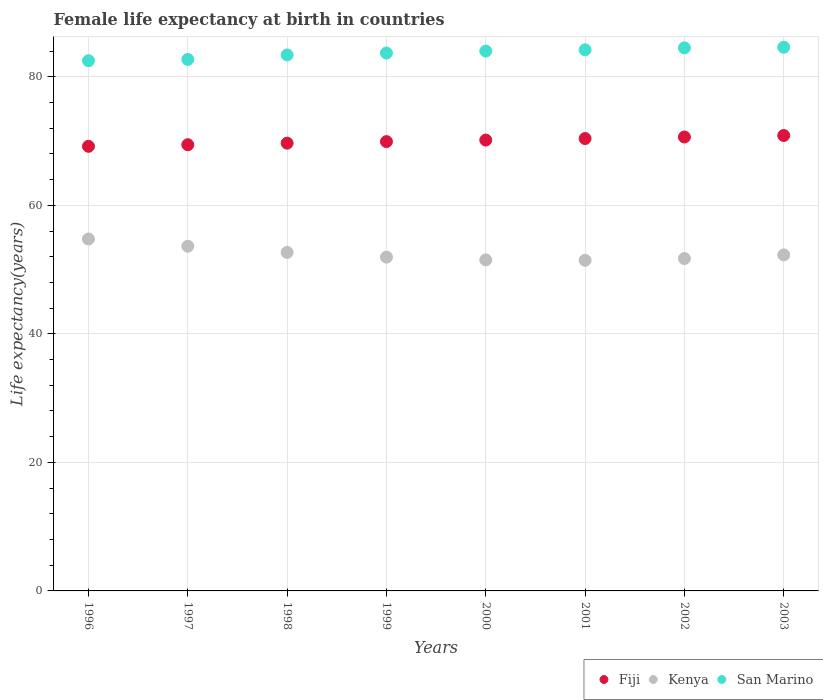How many different coloured dotlines are there?
Give a very brief answer. 3. Is the number of dotlines equal to the number of legend labels?
Your answer should be compact. Yes. What is the female life expectancy at birth in Kenya in 1998?
Offer a very short reply. 52.67. Across all years, what is the maximum female life expectancy at birth in Kenya?
Ensure brevity in your answer.  54.77. Across all years, what is the minimum female life expectancy at birth in Kenya?
Your answer should be very brief. 51.45. In which year was the female life expectancy at birth in San Marino maximum?
Your answer should be compact. 2003. What is the total female life expectancy at birth in Kenya in the graph?
Your answer should be very brief. 419.97. What is the difference between the female life expectancy at birth in Kenya in 1997 and that in 2002?
Offer a very short reply. 1.91. What is the difference between the female life expectancy at birth in San Marino in 1998 and the female life expectancy at birth in Fiji in 2000?
Provide a succinct answer. 13.25. What is the average female life expectancy at birth in Fiji per year?
Keep it short and to the point. 70.03. In the year 1996, what is the difference between the female life expectancy at birth in San Marino and female life expectancy at birth in Fiji?
Give a very brief answer. 13.32. In how many years, is the female life expectancy at birth in Fiji greater than 8 years?
Your answer should be compact. 8. What is the ratio of the female life expectancy at birth in Kenya in 2001 to that in 2002?
Keep it short and to the point. 0.99. Is the female life expectancy at birth in San Marino in 2000 less than that in 2001?
Ensure brevity in your answer.  Yes. Is the difference between the female life expectancy at birth in San Marino in 1998 and 2002 greater than the difference between the female life expectancy at birth in Fiji in 1998 and 2002?
Offer a terse response. No. What is the difference between the highest and the second highest female life expectancy at birth in San Marino?
Your answer should be compact. 0.1. What is the difference between the highest and the lowest female life expectancy at birth in Fiji?
Your answer should be compact. 1.69. Is the sum of the female life expectancy at birth in Kenya in 1997 and 2000 greater than the maximum female life expectancy at birth in Fiji across all years?
Your answer should be very brief. Yes. Is it the case that in every year, the sum of the female life expectancy at birth in Fiji and female life expectancy at birth in San Marino  is greater than the female life expectancy at birth in Kenya?
Offer a terse response. Yes. Does the female life expectancy at birth in San Marino monotonically increase over the years?
Provide a short and direct response. Yes. Is the female life expectancy at birth in San Marino strictly greater than the female life expectancy at birth in Kenya over the years?
Provide a succinct answer. Yes. Is the female life expectancy at birth in San Marino strictly less than the female life expectancy at birth in Kenya over the years?
Keep it short and to the point. No. How many dotlines are there?
Provide a succinct answer. 3. What is the difference between two consecutive major ticks on the Y-axis?
Make the answer very short. 20. Are the values on the major ticks of Y-axis written in scientific E-notation?
Ensure brevity in your answer.  No. Does the graph contain any zero values?
Provide a short and direct response. No. Where does the legend appear in the graph?
Your answer should be compact. Bottom right. How many legend labels are there?
Keep it short and to the point. 3. What is the title of the graph?
Provide a short and direct response. Female life expectancy at birth in countries. What is the label or title of the X-axis?
Provide a succinct answer. Years. What is the label or title of the Y-axis?
Keep it short and to the point. Life expectancy(years). What is the Life expectancy(years) of Fiji in 1996?
Keep it short and to the point. 69.18. What is the Life expectancy(years) in Kenya in 1996?
Provide a succinct answer. 54.77. What is the Life expectancy(years) of San Marino in 1996?
Provide a succinct answer. 82.5. What is the Life expectancy(years) of Fiji in 1997?
Give a very brief answer. 69.43. What is the Life expectancy(years) of Kenya in 1997?
Keep it short and to the point. 53.63. What is the Life expectancy(years) in San Marino in 1997?
Your answer should be very brief. 82.7. What is the Life expectancy(years) of Fiji in 1998?
Make the answer very short. 69.67. What is the Life expectancy(years) of Kenya in 1998?
Give a very brief answer. 52.67. What is the Life expectancy(years) in San Marino in 1998?
Provide a succinct answer. 83.4. What is the Life expectancy(years) of Fiji in 1999?
Make the answer very short. 69.91. What is the Life expectancy(years) in Kenya in 1999?
Provide a short and direct response. 51.94. What is the Life expectancy(years) in San Marino in 1999?
Make the answer very short. 83.7. What is the Life expectancy(years) in Fiji in 2000?
Give a very brief answer. 70.15. What is the Life expectancy(years) of Kenya in 2000?
Give a very brief answer. 51.51. What is the Life expectancy(years) of San Marino in 2000?
Provide a succinct answer. 84. What is the Life expectancy(years) of Fiji in 2001?
Make the answer very short. 70.39. What is the Life expectancy(years) of Kenya in 2001?
Ensure brevity in your answer.  51.45. What is the Life expectancy(years) in San Marino in 2001?
Make the answer very short. 84.2. What is the Life expectancy(years) of Fiji in 2002?
Provide a short and direct response. 70.63. What is the Life expectancy(years) in Kenya in 2002?
Offer a terse response. 51.72. What is the Life expectancy(years) of San Marino in 2002?
Provide a short and direct response. 84.5. What is the Life expectancy(years) of Fiji in 2003?
Make the answer very short. 70.87. What is the Life expectancy(years) of Kenya in 2003?
Offer a very short reply. 52.29. What is the Life expectancy(years) of San Marino in 2003?
Ensure brevity in your answer.  84.6. Across all years, what is the maximum Life expectancy(years) of Fiji?
Provide a short and direct response. 70.87. Across all years, what is the maximum Life expectancy(years) in Kenya?
Keep it short and to the point. 54.77. Across all years, what is the maximum Life expectancy(years) in San Marino?
Ensure brevity in your answer.  84.6. Across all years, what is the minimum Life expectancy(years) in Fiji?
Keep it short and to the point. 69.18. Across all years, what is the minimum Life expectancy(years) of Kenya?
Provide a succinct answer. 51.45. Across all years, what is the minimum Life expectancy(years) of San Marino?
Offer a very short reply. 82.5. What is the total Life expectancy(years) in Fiji in the graph?
Your response must be concise. 560.24. What is the total Life expectancy(years) of Kenya in the graph?
Make the answer very short. 419.97. What is the total Life expectancy(years) of San Marino in the graph?
Ensure brevity in your answer.  669.6. What is the difference between the Life expectancy(years) in Fiji in 1996 and that in 1997?
Provide a succinct answer. -0.25. What is the difference between the Life expectancy(years) of Kenya in 1996 and that in 1997?
Offer a terse response. 1.13. What is the difference between the Life expectancy(years) of San Marino in 1996 and that in 1997?
Provide a succinct answer. -0.2. What is the difference between the Life expectancy(years) in Fiji in 1996 and that in 1998?
Give a very brief answer. -0.49. What is the difference between the Life expectancy(years) of Kenya in 1996 and that in 1998?
Your answer should be compact. 2.1. What is the difference between the Life expectancy(years) of Fiji in 1996 and that in 1999?
Offer a very short reply. -0.73. What is the difference between the Life expectancy(years) of Kenya in 1996 and that in 1999?
Your answer should be compact. 2.83. What is the difference between the Life expectancy(years) in San Marino in 1996 and that in 1999?
Provide a short and direct response. -1.2. What is the difference between the Life expectancy(years) of Fiji in 1996 and that in 2000?
Your response must be concise. -0.97. What is the difference between the Life expectancy(years) in Kenya in 1996 and that in 2000?
Offer a very short reply. 3.25. What is the difference between the Life expectancy(years) in Fiji in 1996 and that in 2001?
Keep it short and to the point. -1.21. What is the difference between the Life expectancy(years) in Kenya in 1996 and that in 2001?
Offer a terse response. 3.32. What is the difference between the Life expectancy(years) of Fiji in 1996 and that in 2002?
Ensure brevity in your answer.  -1.45. What is the difference between the Life expectancy(years) of Kenya in 1996 and that in 2002?
Make the answer very short. 3.04. What is the difference between the Life expectancy(years) of San Marino in 1996 and that in 2002?
Ensure brevity in your answer.  -2. What is the difference between the Life expectancy(years) of Fiji in 1996 and that in 2003?
Your answer should be very brief. -1.69. What is the difference between the Life expectancy(years) of Kenya in 1996 and that in 2003?
Make the answer very short. 2.48. What is the difference between the Life expectancy(years) of San Marino in 1996 and that in 2003?
Provide a succinct answer. -2.1. What is the difference between the Life expectancy(years) in Fiji in 1997 and that in 1998?
Your response must be concise. -0.24. What is the difference between the Life expectancy(years) of Kenya in 1997 and that in 1998?
Offer a very short reply. 0.96. What is the difference between the Life expectancy(years) in San Marino in 1997 and that in 1998?
Your answer should be very brief. -0.7. What is the difference between the Life expectancy(years) of Fiji in 1997 and that in 1999?
Offer a very short reply. -0.48. What is the difference between the Life expectancy(years) in Kenya in 1997 and that in 1999?
Give a very brief answer. 1.7. What is the difference between the Life expectancy(years) of San Marino in 1997 and that in 1999?
Keep it short and to the point. -1. What is the difference between the Life expectancy(years) in Fiji in 1997 and that in 2000?
Make the answer very short. -0.72. What is the difference between the Life expectancy(years) in Kenya in 1997 and that in 2000?
Keep it short and to the point. 2.12. What is the difference between the Life expectancy(years) in San Marino in 1997 and that in 2000?
Offer a terse response. -1.3. What is the difference between the Life expectancy(years) of Fiji in 1997 and that in 2001?
Provide a short and direct response. -0.96. What is the difference between the Life expectancy(years) of Kenya in 1997 and that in 2001?
Provide a short and direct response. 2.19. What is the difference between the Life expectancy(years) of Fiji in 1997 and that in 2002?
Offer a very short reply. -1.2. What is the difference between the Life expectancy(years) in Kenya in 1997 and that in 2002?
Offer a terse response. 1.91. What is the difference between the Life expectancy(years) in Fiji in 1997 and that in 2003?
Provide a short and direct response. -1.44. What is the difference between the Life expectancy(years) in Kenya in 1997 and that in 2003?
Provide a short and direct response. 1.35. What is the difference between the Life expectancy(years) of San Marino in 1997 and that in 2003?
Make the answer very short. -1.9. What is the difference between the Life expectancy(years) in Fiji in 1998 and that in 1999?
Offer a terse response. -0.24. What is the difference between the Life expectancy(years) in Kenya in 1998 and that in 1999?
Keep it short and to the point. 0.73. What is the difference between the Life expectancy(years) in Fiji in 1998 and that in 2000?
Your response must be concise. -0.48. What is the difference between the Life expectancy(years) in Kenya in 1998 and that in 2000?
Offer a very short reply. 1.16. What is the difference between the Life expectancy(years) in Fiji in 1998 and that in 2001?
Offer a terse response. -0.72. What is the difference between the Life expectancy(years) in Kenya in 1998 and that in 2001?
Provide a succinct answer. 1.22. What is the difference between the Life expectancy(years) in Fiji in 1998 and that in 2002?
Make the answer very short. -0.96. What is the difference between the Life expectancy(years) of Kenya in 1998 and that in 2002?
Keep it short and to the point. 0.95. What is the difference between the Life expectancy(years) of San Marino in 1998 and that in 2002?
Provide a succinct answer. -1.1. What is the difference between the Life expectancy(years) in Fiji in 1998 and that in 2003?
Give a very brief answer. -1.19. What is the difference between the Life expectancy(years) of Kenya in 1998 and that in 2003?
Provide a short and direct response. 0.38. What is the difference between the Life expectancy(years) of San Marino in 1998 and that in 2003?
Make the answer very short. -1.2. What is the difference between the Life expectancy(years) in Fiji in 1999 and that in 2000?
Give a very brief answer. -0.24. What is the difference between the Life expectancy(years) in Kenya in 1999 and that in 2000?
Your answer should be very brief. 0.42. What is the difference between the Life expectancy(years) of Fiji in 1999 and that in 2001?
Your response must be concise. -0.48. What is the difference between the Life expectancy(years) in Kenya in 1999 and that in 2001?
Make the answer very short. 0.49. What is the difference between the Life expectancy(years) of Fiji in 1999 and that in 2002?
Offer a terse response. -0.72. What is the difference between the Life expectancy(years) in Kenya in 1999 and that in 2002?
Give a very brief answer. 0.22. What is the difference between the Life expectancy(years) in Fiji in 1999 and that in 2003?
Keep it short and to the point. -0.95. What is the difference between the Life expectancy(years) of Kenya in 1999 and that in 2003?
Give a very brief answer. -0.35. What is the difference between the Life expectancy(years) in Fiji in 2000 and that in 2001?
Your answer should be compact. -0.24. What is the difference between the Life expectancy(years) in Kenya in 2000 and that in 2001?
Give a very brief answer. 0.07. What is the difference between the Life expectancy(years) in San Marino in 2000 and that in 2001?
Ensure brevity in your answer.  -0.2. What is the difference between the Life expectancy(years) of Fiji in 2000 and that in 2002?
Ensure brevity in your answer.  -0.48. What is the difference between the Life expectancy(years) in Kenya in 2000 and that in 2002?
Provide a short and direct response. -0.21. What is the difference between the Life expectancy(years) in San Marino in 2000 and that in 2002?
Offer a terse response. -0.5. What is the difference between the Life expectancy(years) in Fiji in 2000 and that in 2003?
Provide a succinct answer. -0.71. What is the difference between the Life expectancy(years) in Kenya in 2000 and that in 2003?
Your answer should be compact. -0.77. What is the difference between the Life expectancy(years) of San Marino in 2000 and that in 2003?
Give a very brief answer. -0.6. What is the difference between the Life expectancy(years) of Fiji in 2001 and that in 2002?
Your answer should be very brief. -0.24. What is the difference between the Life expectancy(years) of Kenya in 2001 and that in 2002?
Keep it short and to the point. -0.27. What is the difference between the Life expectancy(years) of San Marino in 2001 and that in 2002?
Ensure brevity in your answer.  -0.3. What is the difference between the Life expectancy(years) of Fiji in 2001 and that in 2003?
Your response must be concise. -0.47. What is the difference between the Life expectancy(years) in Kenya in 2001 and that in 2003?
Offer a very short reply. -0.84. What is the difference between the Life expectancy(years) of Fiji in 2002 and that in 2003?
Keep it short and to the point. -0.24. What is the difference between the Life expectancy(years) of Kenya in 2002 and that in 2003?
Your response must be concise. -0.57. What is the difference between the Life expectancy(years) of San Marino in 2002 and that in 2003?
Keep it short and to the point. -0.1. What is the difference between the Life expectancy(years) in Fiji in 1996 and the Life expectancy(years) in Kenya in 1997?
Give a very brief answer. 15.55. What is the difference between the Life expectancy(years) in Fiji in 1996 and the Life expectancy(years) in San Marino in 1997?
Offer a very short reply. -13.52. What is the difference between the Life expectancy(years) of Kenya in 1996 and the Life expectancy(years) of San Marino in 1997?
Provide a succinct answer. -27.93. What is the difference between the Life expectancy(years) in Fiji in 1996 and the Life expectancy(years) in Kenya in 1998?
Provide a succinct answer. 16.51. What is the difference between the Life expectancy(years) of Fiji in 1996 and the Life expectancy(years) of San Marino in 1998?
Keep it short and to the point. -14.22. What is the difference between the Life expectancy(years) in Kenya in 1996 and the Life expectancy(years) in San Marino in 1998?
Provide a short and direct response. -28.64. What is the difference between the Life expectancy(years) of Fiji in 1996 and the Life expectancy(years) of Kenya in 1999?
Give a very brief answer. 17.25. What is the difference between the Life expectancy(years) in Fiji in 1996 and the Life expectancy(years) in San Marino in 1999?
Ensure brevity in your answer.  -14.52. What is the difference between the Life expectancy(years) in Kenya in 1996 and the Life expectancy(years) in San Marino in 1999?
Your response must be concise. -28.93. What is the difference between the Life expectancy(years) of Fiji in 1996 and the Life expectancy(years) of Kenya in 2000?
Offer a terse response. 17.67. What is the difference between the Life expectancy(years) of Fiji in 1996 and the Life expectancy(years) of San Marino in 2000?
Provide a succinct answer. -14.82. What is the difference between the Life expectancy(years) of Kenya in 1996 and the Life expectancy(years) of San Marino in 2000?
Keep it short and to the point. -29.23. What is the difference between the Life expectancy(years) of Fiji in 1996 and the Life expectancy(years) of Kenya in 2001?
Your answer should be very brief. 17.73. What is the difference between the Life expectancy(years) of Fiji in 1996 and the Life expectancy(years) of San Marino in 2001?
Give a very brief answer. -15.02. What is the difference between the Life expectancy(years) in Kenya in 1996 and the Life expectancy(years) in San Marino in 2001?
Your answer should be compact. -29.43. What is the difference between the Life expectancy(years) in Fiji in 1996 and the Life expectancy(years) in Kenya in 2002?
Give a very brief answer. 17.46. What is the difference between the Life expectancy(years) of Fiji in 1996 and the Life expectancy(years) of San Marino in 2002?
Your response must be concise. -15.32. What is the difference between the Life expectancy(years) in Kenya in 1996 and the Life expectancy(years) in San Marino in 2002?
Make the answer very short. -29.73. What is the difference between the Life expectancy(years) in Fiji in 1996 and the Life expectancy(years) in Kenya in 2003?
Your response must be concise. 16.9. What is the difference between the Life expectancy(years) in Fiji in 1996 and the Life expectancy(years) in San Marino in 2003?
Provide a succinct answer. -15.42. What is the difference between the Life expectancy(years) in Kenya in 1996 and the Life expectancy(years) in San Marino in 2003?
Provide a short and direct response. -29.84. What is the difference between the Life expectancy(years) of Fiji in 1997 and the Life expectancy(years) of Kenya in 1998?
Offer a terse response. 16.76. What is the difference between the Life expectancy(years) of Fiji in 1997 and the Life expectancy(years) of San Marino in 1998?
Offer a very short reply. -13.97. What is the difference between the Life expectancy(years) of Kenya in 1997 and the Life expectancy(years) of San Marino in 1998?
Offer a very short reply. -29.77. What is the difference between the Life expectancy(years) in Fiji in 1997 and the Life expectancy(years) in Kenya in 1999?
Offer a terse response. 17.49. What is the difference between the Life expectancy(years) of Fiji in 1997 and the Life expectancy(years) of San Marino in 1999?
Keep it short and to the point. -14.27. What is the difference between the Life expectancy(years) in Kenya in 1997 and the Life expectancy(years) in San Marino in 1999?
Keep it short and to the point. -30.07. What is the difference between the Life expectancy(years) in Fiji in 1997 and the Life expectancy(years) in Kenya in 2000?
Your response must be concise. 17.92. What is the difference between the Life expectancy(years) in Fiji in 1997 and the Life expectancy(years) in San Marino in 2000?
Your answer should be very brief. -14.57. What is the difference between the Life expectancy(years) of Kenya in 1997 and the Life expectancy(years) of San Marino in 2000?
Provide a short and direct response. -30.37. What is the difference between the Life expectancy(years) of Fiji in 1997 and the Life expectancy(years) of Kenya in 2001?
Offer a terse response. 17.98. What is the difference between the Life expectancy(years) of Fiji in 1997 and the Life expectancy(years) of San Marino in 2001?
Offer a very short reply. -14.77. What is the difference between the Life expectancy(years) of Kenya in 1997 and the Life expectancy(years) of San Marino in 2001?
Your answer should be very brief. -30.57. What is the difference between the Life expectancy(years) in Fiji in 1997 and the Life expectancy(years) in Kenya in 2002?
Offer a terse response. 17.71. What is the difference between the Life expectancy(years) in Fiji in 1997 and the Life expectancy(years) in San Marino in 2002?
Ensure brevity in your answer.  -15.07. What is the difference between the Life expectancy(years) of Kenya in 1997 and the Life expectancy(years) of San Marino in 2002?
Give a very brief answer. -30.87. What is the difference between the Life expectancy(years) in Fiji in 1997 and the Life expectancy(years) in Kenya in 2003?
Your response must be concise. 17.14. What is the difference between the Life expectancy(years) of Fiji in 1997 and the Life expectancy(years) of San Marino in 2003?
Ensure brevity in your answer.  -15.17. What is the difference between the Life expectancy(years) in Kenya in 1997 and the Life expectancy(years) in San Marino in 2003?
Provide a short and direct response. -30.97. What is the difference between the Life expectancy(years) of Fiji in 1998 and the Life expectancy(years) of Kenya in 1999?
Your response must be concise. 17.74. What is the difference between the Life expectancy(years) of Fiji in 1998 and the Life expectancy(years) of San Marino in 1999?
Provide a short and direct response. -14.03. What is the difference between the Life expectancy(years) in Kenya in 1998 and the Life expectancy(years) in San Marino in 1999?
Your answer should be compact. -31.03. What is the difference between the Life expectancy(years) of Fiji in 1998 and the Life expectancy(years) of Kenya in 2000?
Give a very brief answer. 18.16. What is the difference between the Life expectancy(years) of Fiji in 1998 and the Life expectancy(years) of San Marino in 2000?
Make the answer very short. -14.33. What is the difference between the Life expectancy(years) of Kenya in 1998 and the Life expectancy(years) of San Marino in 2000?
Your answer should be compact. -31.33. What is the difference between the Life expectancy(years) of Fiji in 1998 and the Life expectancy(years) of Kenya in 2001?
Offer a very short reply. 18.23. What is the difference between the Life expectancy(years) of Fiji in 1998 and the Life expectancy(years) of San Marino in 2001?
Your answer should be very brief. -14.53. What is the difference between the Life expectancy(years) in Kenya in 1998 and the Life expectancy(years) in San Marino in 2001?
Provide a succinct answer. -31.53. What is the difference between the Life expectancy(years) of Fiji in 1998 and the Life expectancy(years) of Kenya in 2002?
Your answer should be compact. 17.95. What is the difference between the Life expectancy(years) of Fiji in 1998 and the Life expectancy(years) of San Marino in 2002?
Your answer should be compact. -14.83. What is the difference between the Life expectancy(years) of Kenya in 1998 and the Life expectancy(years) of San Marino in 2002?
Make the answer very short. -31.83. What is the difference between the Life expectancy(years) in Fiji in 1998 and the Life expectancy(years) in Kenya in 2003?
Offer a terse response. 17.39. What is the difference between the Life expectancy(years) in Fiji in 1998 and the Life expectancy(years) in San Marino in 2003?
Your response must be concise. -14.93. What is the difference between the Life expectancy(years) of Kenya in 1998 and the Life expectancy(years) of San Marino in 2003?
Your answer should be compact. -31.93. What is the difference between the Life expectancy(years) of Fiji in 1999 and the Life expectancy(years) of Kenya in 2000?
Offer a terse response. 18.4. What is the difference between the Life expectancy(years) in Fiji in 1999 and the Life expectancy(years) in San Marino in 2000?
Offer a very short reply. -14.09. What is the difference between the Life expectancy(years) in Kenya in 1999 and the Life expectancy(years) in San Marino in 2000?
Your response must be concise. -32.06. What is the difference between the Life expectancy(years) of Fiji in 1999 and the Life expectancy(years) of Kenya in 2001?
Provide a succinct answer. 18.47. What is the difference between the Life expectancy(years) in Fiji in 1999 and the Life expectancy(years) in San Marino in 2001?
Your answer should be compact. -14.29. What is the difference between the Life expectancy(years) of Kenya in 1999 and the Life expectancy(years) of San Marino in 2001?
Ensure brevity in your answer.  -32.26. What is the difference between the Life expectancy(years) of Fiji in 1999 and the Life expectancy(years) of Kenya in 2002?
Your response must be concise. 18.19. What is the difference between the Life expectancy(years) of Fiji in 1999 and the Life expectancy(years) of San Marino in 2002?
Provide a short and direct response. -14.59. What is the difference between the Life expectancy(years) of Kenya in 1999 and the Life expectancy(years) of San Marino in 2002?
Ensure brevity in your answer.  -32.56. What is the difference between the Life expectancy(years) of Fiji in 1999 and the Life expectancy(years) of Kenya in 2003?
Give a very brief answer. 17.63. What is the difference between the Life expectancy(years) in Fiji in 1999 and the Life expectancy(years) in San Marino in 2003?
Make the answer very short. -14.69. What is the difference between the Life expectancy(years) of Kenya in 1999 and the Life expectancy(years) of San Marino in 2003?
Make the answer very short. -32.66. What is the difference between the Life expectancy(years) of Fiji in 2000 and the Life expectancy(years) of Kenya in 2001?
Your answer should be very brief. 18.7. What is the difference between the Life expectancy(years) in Fiji in 2000 and the Life expectancy(years) in San Marino in 2001?
Your answer should be very brief. -14.05. What is the difference between the Life expectancy(years) of Kenya in 2000 and the Life expectancy(years) of San Marino in 2001?
Make the answer very short. -32.69. What is the difference between the Life expectancy(years) of Fiji in 2000 and the Life expectancy(years) of Kenya in 2002?
Provide a succinct answer. 18.43. What is the difference between the Life expectancy(years) in Fiji in 2000 and the Life expectancy(years) in San Marino in 2002?
Offer a terse response. -14.35. What is the difference between the Life expectancy(years) of Kenya in 2000 and the Life expectancy(years) of San Marino in 2002?
Ensure brevity in your answer.  -32.99. What is the difference between the Life expectancy(years) of Fiji in 2000 and the Life expectancy(years) of Kenya in 2003?
Make the answer very short. 17.87. What is the difference between the Life expectancy(years) in Fiji in 2000 and the Life expectancy(years) in San Marino in 2003?
Ensure brevity in your answer.  -14.45. What is the difference between the Life expectancy(years) of Kenya in 2000 and the Life expectancy(years) of San Marino in 2003?
Ensure brevity in your answer.  -33.09. What is the difference between the Life expectancy(years) in Fiji in 2001 and the Life expectancy(years) in Kenya in 2002?
Your response must be concise. 18.67. What is the difference between the Life expectancy(years) in Fiji in 2001 and the Life expectancy(years) in San Marino in 2002?
Your response must be concise. -14.11. What is the difference between the Life expectancy(years) in Kenya in 2001 and the Life expectancy(years) in San Marino in 2002?
Ensure brevity in your answer.  -33.05. What is the difference between the Life expectancy(years) of Fiji in 2001 and the Life expectancy(years) of Kenya in 2003?
Offer a terse response. 18.11. What is the difference between the Life expectancy(years) of Fiji in 2001 and the Life expectancy(years) of San Marino in 2003?
Offer a terse response. -14.21. What is the difference between the Life expectancy(years) of Kenya in 2001 and the Life expectancy(years) of San Marino in 2003?
Provide a short and direct response. -33.15. What is the difference between the Life expectancy(years) in Fiji in 2002 and the Life expectancy(years) in Kenya in 2003?
Your answer should be compact. 18.34. What is the difference between the Life expectancy(years) of Fiji in 2002 and the Life expectancy(years) of San Marino in 2003?
Offer a very short reply. -13.97. What is the difference between the Life expectancy(years) in Kenya in 2002 and the Life expectancy(years) in San Marino in 2003?
Ensure brevity in your answer.  -32.88. What is the average Life expectancy(years) in Fiji per year?
Your answer should be compact. 70.03. What is the average Life expectancy(years) in Kenya per year?
Your answer should be very brief. 52.5. What is the average Life expectancy(years) of San Marino per year?
Make the answer very short. 83.7. In the year 1996, what is the difference between the Life expectancy(years) in Fiji and Life expectancy(years) in Kenya?
Make the answer very short. 14.42. In the year 1996, what is the difference between the Life expectancy(years) in Fiji and Life expectancy(years) in San Marino?
Ensure brevity in your answer.  -13.32. In the year 1996, what is the difference between the Life expectancy(years) in Kenya and Life expectancy(years) in San Marino?
Keep it short and to the point. -27.73. In the year 1997, what is the difference between the Life expectancy(years) of Fiji and Life expectancy(years) of Kenya?
Offer a terse response. 15.8. In the year 1997, what is the difference between the Life expectancy(years) in Fiji and Life expectancy(years) in San Marino?
Give a very brief answer. -13.27. In the year 1997, what is the difference between the Life expectancy(years) of Kenya and Life expectancy(years) of San Marino?
Your answer should be compact. -29.07. In the year 1998, what is the difference between the Life expectancy(years) in Fiji and Life expectancy(years) in Kenya?
Offer a very short reply. 17. In the year 1998, what is the difference between the Life expectancy(years) of Fiji and Life expectancy(years) of San Marino?
Keep it short and to the point. -13.73. In the year 1998, what is the difference between the Life expectancy(years) in Kenya and Life expectancy(years) in San Marino?
Offer a terse response. -30.73. In the year 1999, what is the difference between the Life expectancy(years) of Fiji and Life expectancy(years) of Kenya?
Provide a succinct answer. 17.98. In the year 1999, what is the difference between the Life expectancy(years) in Fiji and Life expectancy(years) in San Marino?
Give a very brief answer. -13.79. In the year 1999, what is the difference between the Life expectancy(years) in Kenya and Life expectancy(years) in San Marino?
Provide a succinct answer. -31.76. In the year 2000, what is the difference between the Life expectancy(years) of Fiji and Life expectancy(years) of Kenya?
Offer a very short reply. 18.64. In the year 2000, what is the difference between the Life expectancy(years) of Fiji and Life expectancy(years) of San Marino?
Your response must be concise. -13.85. In the year 2000, what is the difference between the Life expectancy(years) of Kenya and Life expectancy(years) of San Marino?
Provide a short and direct response. -32.49. In the year 2001, what is the difference between the Life expectancy(years) in Fiji and Life expectancy(years) in Kenya?
Offer a very short reply. 18.94. In the year 2001, what is the difference between the Life expectancy(years) of Fiji and Life expectancy(years) of San Marino?
Your response must be concise. -13.81. In the year 2001, what is the difference between the Life expectancy(years) in Kenya and Life expectancy(years) in San Marino?
Ensure brevity in your answer.  -32.75. In the year 2002, what is the difference between the Life expectancy(years) of Fiji and Life expectancy(years) of Kenya?
Provide a short and direct response. 18.91. In the year 2002, what is the difference between the Life expectancy(years) of Fiji and Life expectancy(years) of San Marino?
Your response must be concise. -13.87. In the year 2002, what is the difference between the Life expectancy(years) of Kenya and Life expectancy(years) of San Marino?
Your answer should be compact. -32.78. In the year 2003, what is the difference between the Life expectancy(years) of Fiji and Life expectancy(years) of Kenya?
Your response must be concise. 18.58. In the year 2003, what is the difference between the Life expectancy(years) in Fiji and Life expectancy(years) in San Marino?
Your answer should be very brief. -13.73. In the year 2003, what is the difference between the Life expectancy(years) of Kenya and Life expectancy(years) of San Marino?
Offer a very short reply. -32.31. What is the ratio of the Life expectancy(years) of Kenya in 1996 to that in 1997?
Give a very brief answer. 1.02. What is the ratio of the Life expectancy(years) in San Marino in 1996 to that in 1997?
Offer a terse response. 1. What is the ratio of the Life expectancy(years) of Fiji in 1996 to that in 1998?
Offer a terse response. 0.99. What is the ratio of the Life expectancy(years) of Kenya in 1996 to that in 1998?
Make the answer very short. 1.04. What is the ratio of the Life expectancy(years) of San Marino in 1996 to that in 1998?
Provide a short and direct response. 0.99. What is the ratio of the Life expectancy(years) in Kenya in 1996 to that in 1999?
Keep it short and to the point. 1.05. What is the ratio of the Life expectancy(years) of San Marino in 1996 to that in 1999?
Ensure brevity in your answer.  0.99. What is the ratio of the Life expectancy(years) in Fiji in 1996 to that in 2000?
Your answer should be compact. 0.99. What is the ratio of the Life expectancy(years) of Kenya in 1996 to that in 2000?
Ensure brevity in your answer.  1.06. What is the ratio of the Life expectancy(years) of San Marino in 1996 to that in 2000?
Provide a succinct answer. 0.98. What is the ratio of the Life expectancy(years) in Fiji in 1996 to that in 2001?
Ensure brevity in your answer.  0.98. What is the ratio of the Life expectancy(years) in Kenya in 1996 to that in 2001?
Offer a very short reply. 1.06. What is the ratio of the Life expectancy(years) of San Marino in 1996 to that in 2001?
Offer a terse response. 0.98. What is the ratio of the Life expectancy(years) in Fiji in 1996 to that in 2002?
Offer a very short reply. 0.98. What is the ratio of the Life expectancy(years) of Kenya in 1996 to that in 2002?
Give a very brief answer. 1.06. What is the ratio of the Life expectancy(years) in San Marino in 1996 to that in 2002?
Offer a very short reply. 0.98. What is the ratio of the Life expectancy(years) in Fiji in 1996 to that in 2003?
Your response must be concise. 0.98. What is the ratio of the Life expectancy(years) of Kenya in 1996 to that in 2003?
Your answer should be compact. 1.05. What is the ratio of the Life expectancy(years) in San Marino in 1996 to that in 2003?
Keep it short and to the point. 0.98. What is the ratio of the Life expectancy(years) of Kenya in 1997 to that in 1998?
Offer a terse response. 1.02. What is the ratio of the Life expectancy(years) in Fiji in 1997 to that in 1999?
Make the answer very short. 0.99. What is the ratio of the Life expectancy(years) of Kenya in 1997 to that in 1999?
Your answer should be very brief. 1.03. What is the ratio of the Life expectancy(years) of Kenya in 1997 to that in 2000?
Your answer should be compact. 1.04. What is the ratio of the Life expectancy(years) in San Marino in 1997 to that in 2000?
Your response must be concise. 0.98. What is the ratio of the Life expectancy(years) of Fiji in 1997 to that in 2001?
Ensure brevity in your answer.  0.99. What is the ratio of the Life expectancy(years) in Kenya in 1997 to that in 2001?
Offer a very short reply. 1.04. What is the ratio of the Life expectancy(years) in San Marino in 1997 to that in 2001?
Give a very brief answer. 0.98. What is the ratio of the Life expectancy(years) in Kenya in 1997 to that in 2002?
Your answer should be very brief. 1.04. What is the ratio of the Life expectancy(years) in San Marino in 1997 to that in 2002?
Your answer should be compact. 0.98. What is the ratio of the Life expectancy(years) in Fiji in 1997 to that in 2003?
Keep it short and to the point. 0.98. What is the ratio of the Life expectancy(years) of Kenya in 1997 to that in 2003?
Give a very brief answer. 1.03. What is the ratio of the Life expectancy(years) of San Marino in 1997 to that in 2003?
Your response must be concise. 0.98. What is the ratio of the Life expectancy(years) of Kenya in 1998 to that in 1999?
Keep it short and to the point. 1.01. What is the ratio of the Life expectancy(years) in Fiji in 1998 to that in 2000?
Make the answer very short. 0.99. What is the ratio of the Life expectancy(years) in Kenya in 1998 to that in 2000?
Provide a short and direct response. 1.02. What is the ratio of the Life expectancy(years) in San Marino in 1998 to that in 2000?
Keep it short and to the point. 0.99. What is the ratio of the Life expectancy(years) of Kenya in 1998 to that in 2001?
Your answer should be compact. 1.02. What is the ratio of the Life expectancy(years) of San Marino in 1998 to that in 2001?
Your answer should be very brief. 0.99. What is the ratio of the Life expectancy(years) of Fiji in 1998 to that in 2002?
Provide a succinct answer. 0.99. What is the ratio of the Life expectancy(years) in Kenya in 1998 to that in 2002?
Give a very brief answer. 1.02. What is the ratio of the Life expectancy(years) of Fiji in 1998 to that in 2003?
Your answer should be compact. 0.98. What is the ratio of the Life expectancy(years) of Kenya in 1998 to that in 2003?
Your response must be concise. 1.01. What is the ratio of the Life expectancy(years) of San Marino in 1998 to that in 2003?
Provide a short and direct response. 0.99. What is the ratio of the Life expectancy(years) in Kenya in 1999 to that in 2000?
Your answer should be compact. 1.01. What is the ratio of the Life expectancy(years) of San Marino in 1999 to that in 2000?
Offer a terse response. 1. What is the ratio of the Life expectancy(years) of Kenya in 1999 to that in 2001?
Offer a terse response. 1.01. What is the ratio of the Life expectancy(years) in San Marino in 1999 to that in 2001?
Offer a very short reply. 0.99. What is the ratio of the Life expectancy(years) of Kenya in 1999 to that in 2002?
Keep it short and to the point. 1. What is the ratio of the Life expectancy(years) in San Marino in 1999 to that in 2002?
Keep it short and to the point. 0.99. What is the ratio of the Life expectancy(years) in Fiji in 1999 to that in 2003?
Make the answer very short. 0.99. What is the ratio of the Life expectancy(years) of Kenya in 2000 to that in 2001?
Provide a short and direct response. 1. What is the ratio of the Life expectancy(years) in San Marino in 2000 to that in 2001?
Offer a very short reply. 1. What is the ratio of the Life expectancy(years) in Fiji in 2000 to that in 2002?
Give a very brief answer. 0.99. What is the ratio of the Life expectancy(years) of Kenya in 2000 to that in 2002?
Ensure brevity in your answer.  1. What is the ratio of the Life expectancy(years) in Fiji in 2000 to that in 2003?
Your answer should be very brief. 0.99. What is the ratio of the Life expectancy(years) in Kenya in 2000 to that in 2003?
Your response must be concise. 0.99. What is the ratio of the Life expectancy(years) in San Marino in 2000 to that in 2003?
Offer a very short reply. 0.99. What is the ratio of the Life expectancy(years) in Kenya in 2001 to that in 2002?
Make the answer very short. 0.99. What is the ratio of the Life expectancy(years) of San Marino in 2001 to that in 2002?
Make the answer very short. 1. What is the ratio of the Life expectancy(years) in Fiji in 2001 to that in 2003?
Keep it short and to the point. 0.99. What is the ratio of the Life expectancy(years) in Kenya in 2001 to that in 2003?
Provide a succinct answer. 0.98. What is the ratio of the Life expectancy(years) of San Marino in 2001 to that in 2003?
Offer a terse response. 1. What is the ratio of the Life expectancy(years) in Fiji in 2002 to that in 2003?
Make the answer very short. 1. What is the ratio of the Life expectancy(years) of Kenya in 2002 to that in 2003?
Give a very brief answer. 0.99. What is the ratio of the Life expectancy(years) in San Marino in 2002 to that in 2003?
Provide a succinct answer. 1. What is the difference between the highest and the second highest Life expectancy(years) in Fiji?
Keep it short and to the point. 0.24. What is the difference between the highest and the second highest Life expectancy(years) in Kenya?
Keep it short and to the point. 1.13. What is the difference between the highest and the lowest Life expectancy(years) of Fiji?
Offer a terse response. 1.69. What is the difference between the highest and the lowest Life expectancy(years) in Kenya?
Your response must be concise. 3.32. 